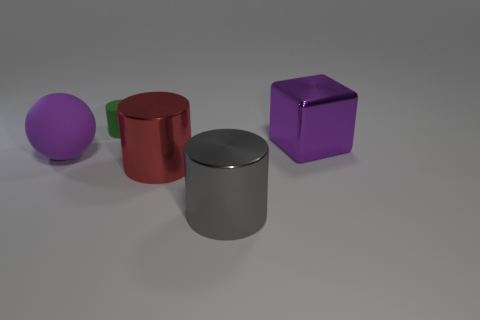Add 2 cylinders. How many objects exist? 7 Subtract all cylinders. How many objects are left? 2 Add 5 big purple balls. How many big purple balls are left? 6 Add 4 matte balls. How many matte balls exist? 5 Subtract 1 purple cubes. How many objects are left? 4 Subtract all big cylinders. Subtract all big purple shiny cubes. How many objects are left? 2 